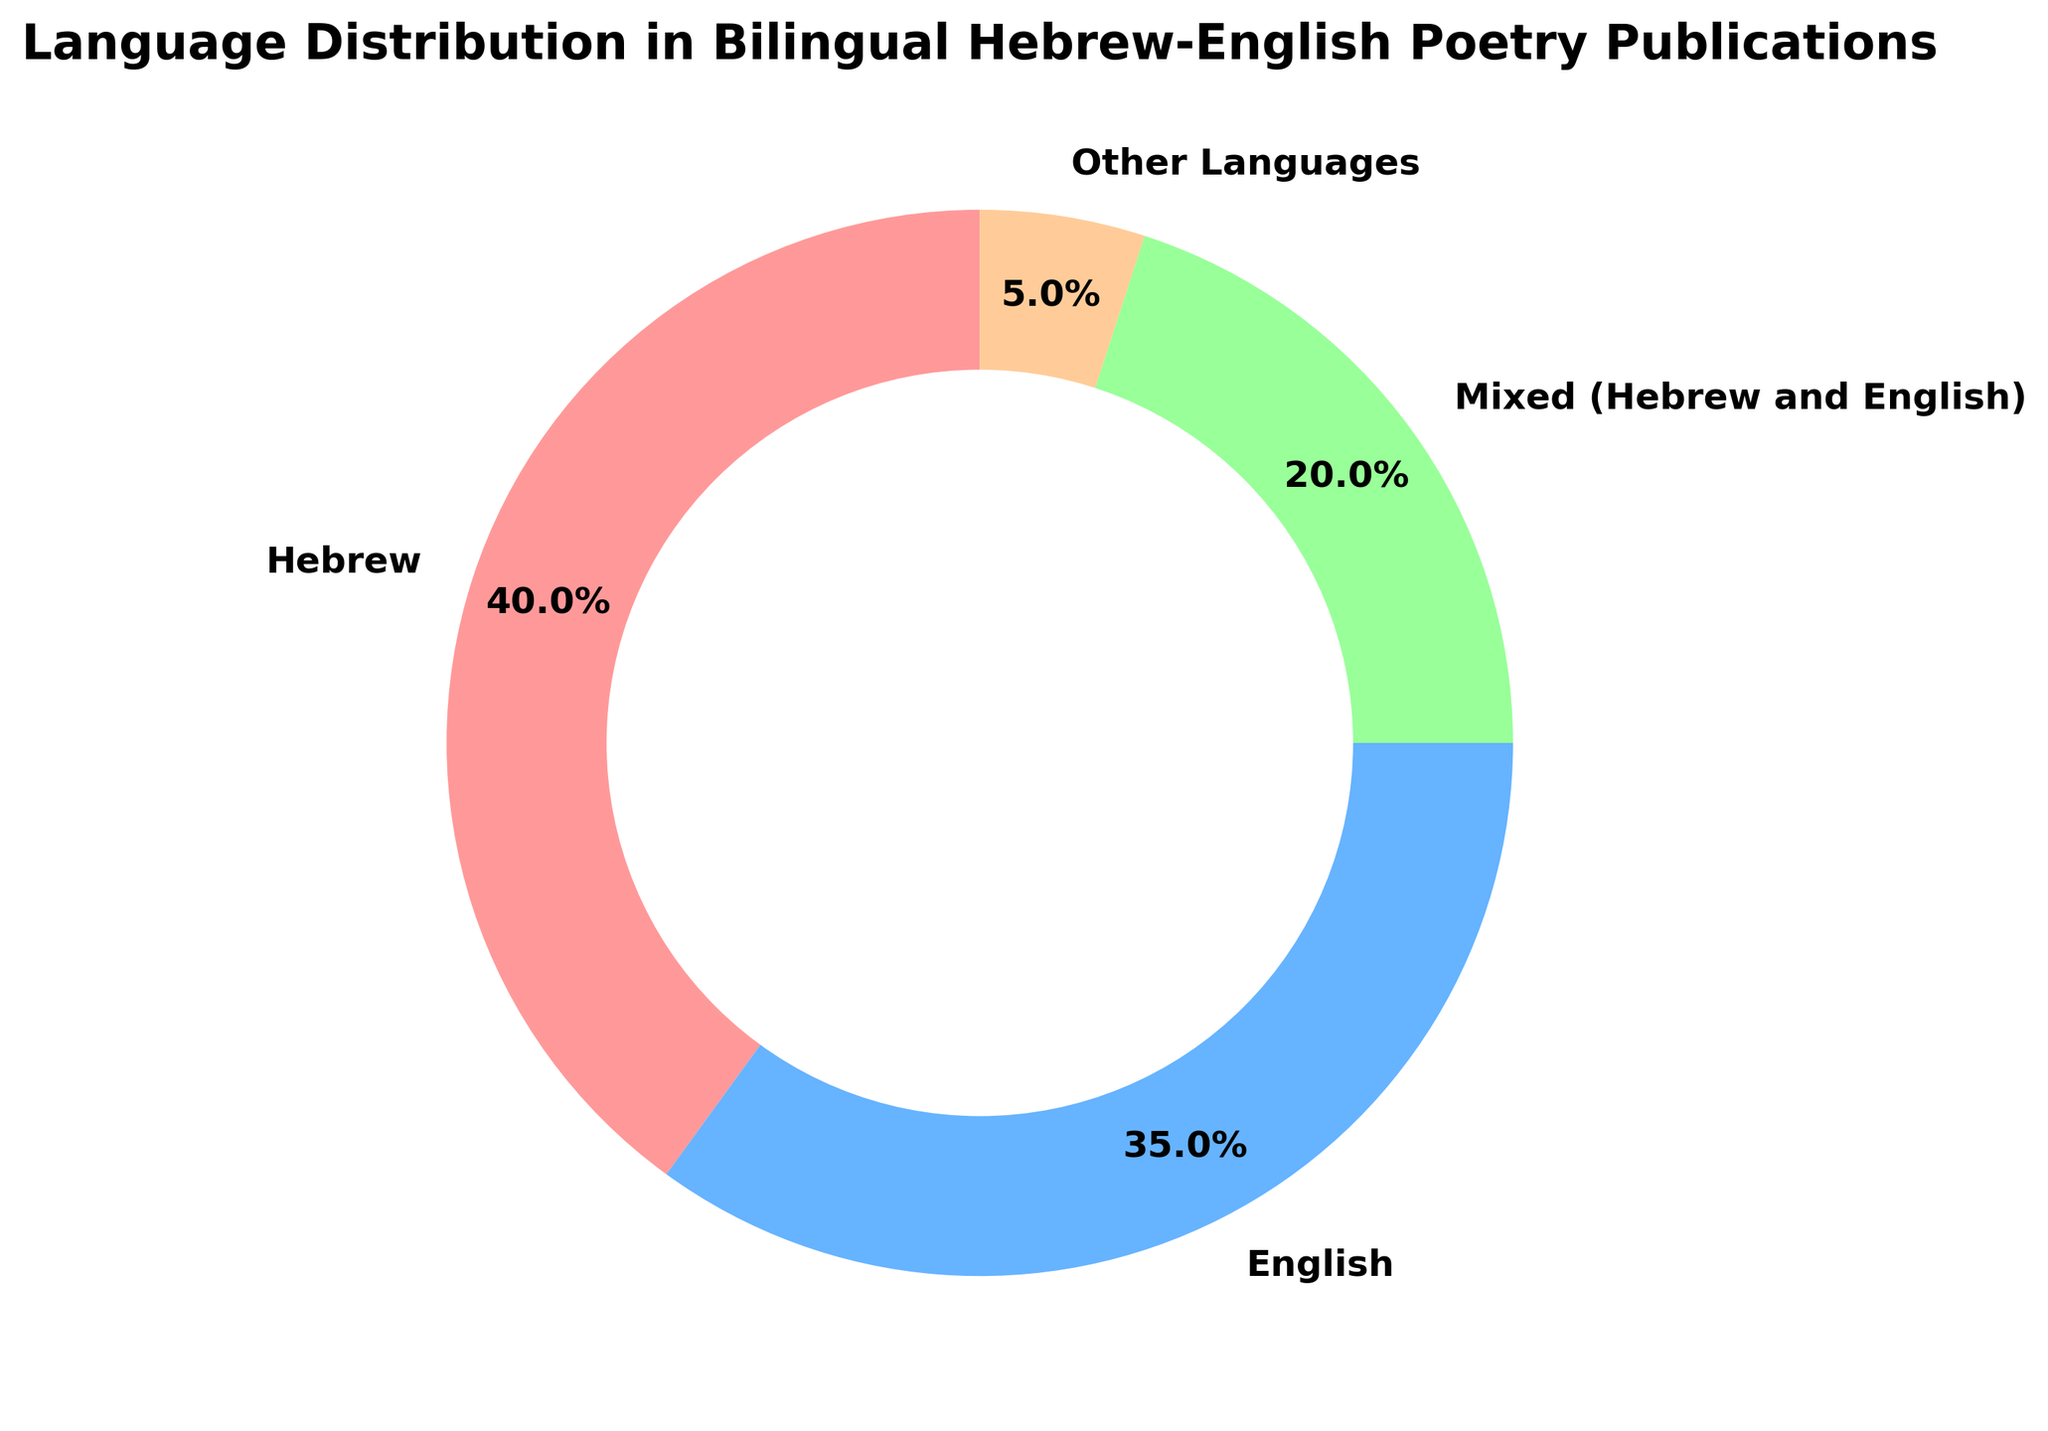What percentage of publications are in languages other than Hebrew and English? The slice labeled "Other Languages" represents the percentage of publications not in Hebrew and English. It states 5%.
Answer: 5% Which language has the largest share of the pie chart? By looking at the sizes of the slices, the "Hebrew" slice is the largest with 40%.
Answer: Hebrew What is the combined percentage of publications that are either exclusively in English or are mixed? Add the percentages for "English" and "Mixed (Hebrew and English)": 35% + 20% = 55%.
Answer: 55% How does the percentage of Hebrew publications compare to that of English-only publications? Hebrew publications have a percentage of 40%, and English-only publications have 35%. Comparing these two, Hebrew has a higher percentage.
Answer: Hebrew has a higher percentage Which language group has the smallest percentage and what is that percentage? The slice for "Other Languages" is the smallest, labeled with a percentage of 5%.
Answer: Other Languages, 5% How much larger is the percentage of Hebrew publications than the percentage of publications in other languages? The percentage for Hebrew is 40%, and Other Languages is 5%. The difference is 40% - 5% = 35%.
Answer: 35% Considering the percentage for Mixed publications, how many times greater is it than the percentage for Other Languages? Mixed publications have a percentage of 20%, and Other Languages have 5%. Calculate the ratio: 20% / 5% = 4.
Answer: 4 times Is the percentage of Mixed publications closer to the percentage of Hebrew publications or English publications? Mixed publications are 20%. The difference with Hebrew (40%) is 20%, and with English (35%) is 15%. 20% is closer to English.
Answer: English What is the average percentage of publications across all language groups? Add the percentages: 40% (Hebrew) + 35% (English) + 20% (Mixed) + 5% (Other) = 100%. Divide by 4 groups: 100% / 4 = 25%.
Answer: 25% 